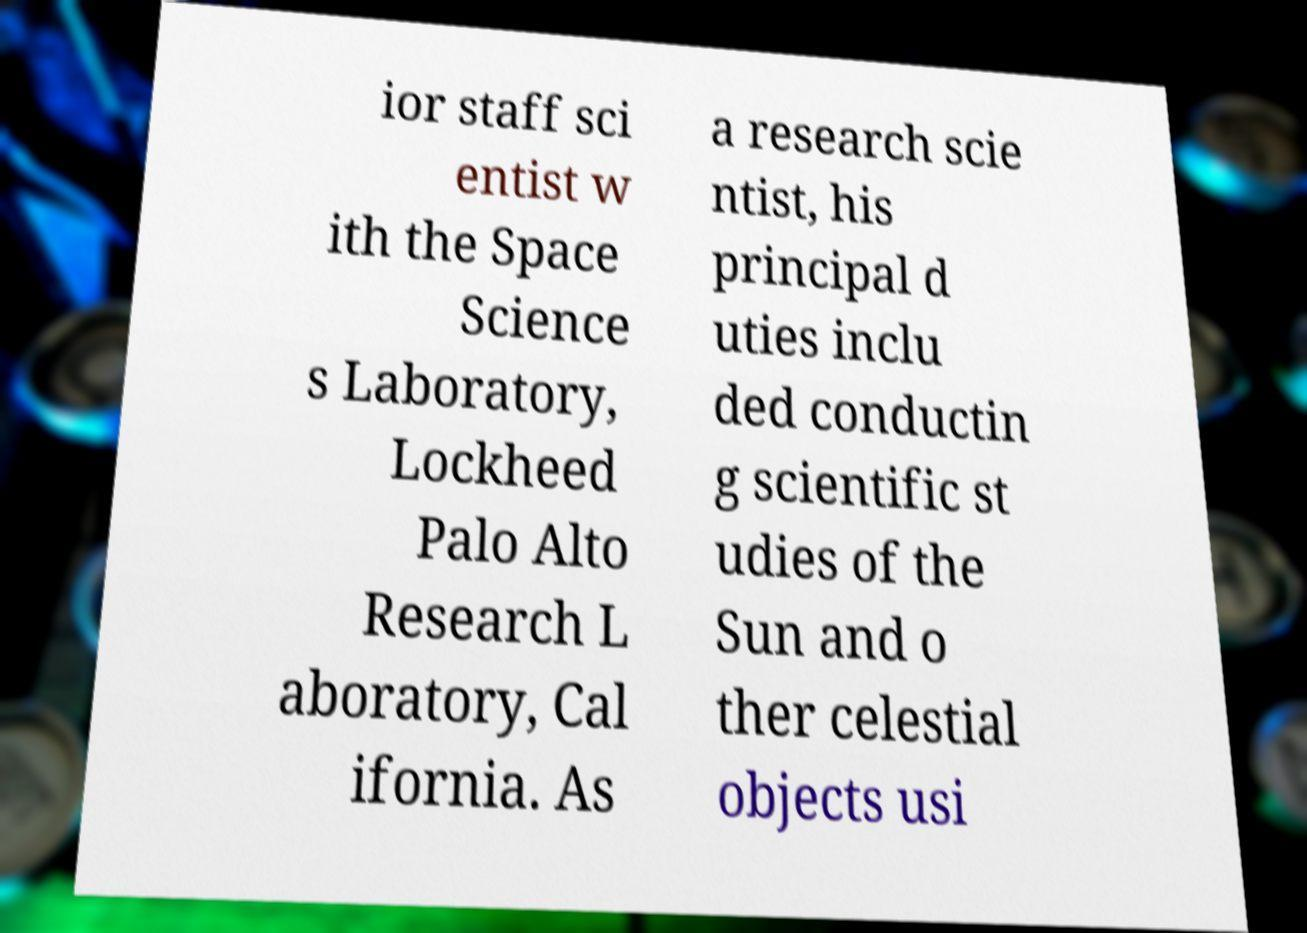Can you accurately transcribe the text from the provided image for me? ior staff sci entist w ith the Space Science s Laboratory, Lockheed Palo Alto Research L aboratory, Cal ifornia. As a research scie ntist, his principal d uties inclu ded conductin g scientific st udies of the Sun and o ther celestial objects usi 